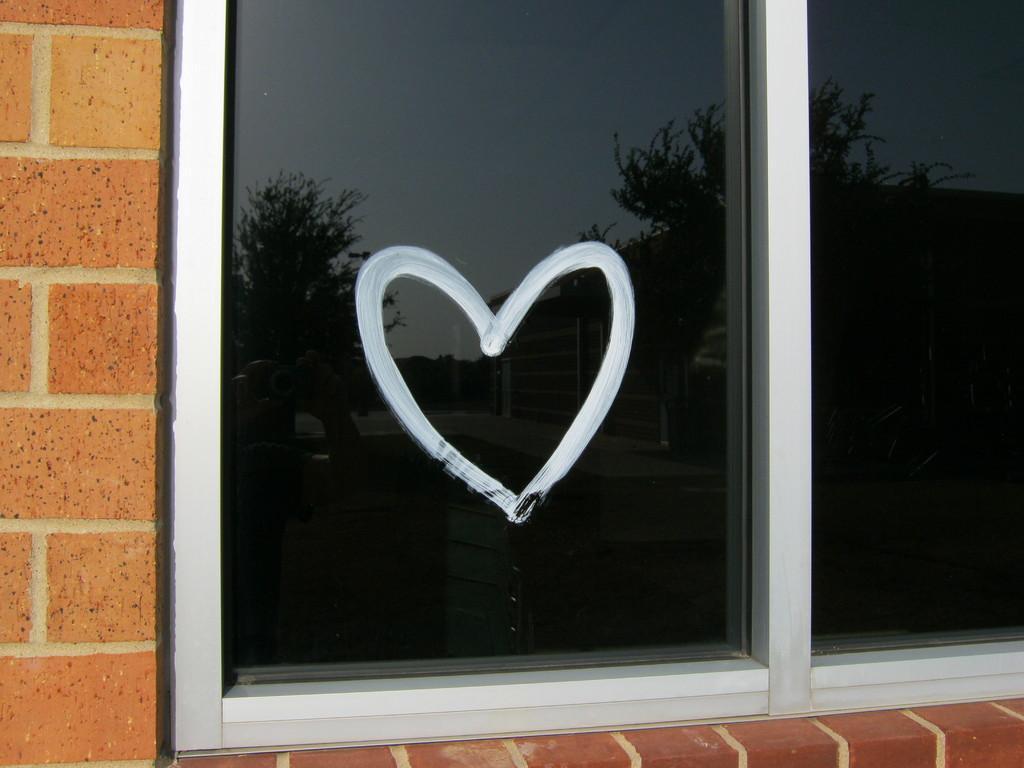How would you summarize this image in a sentence or two? In this image in front there is a wall with the glass window and we can see a heart symbol on it. 